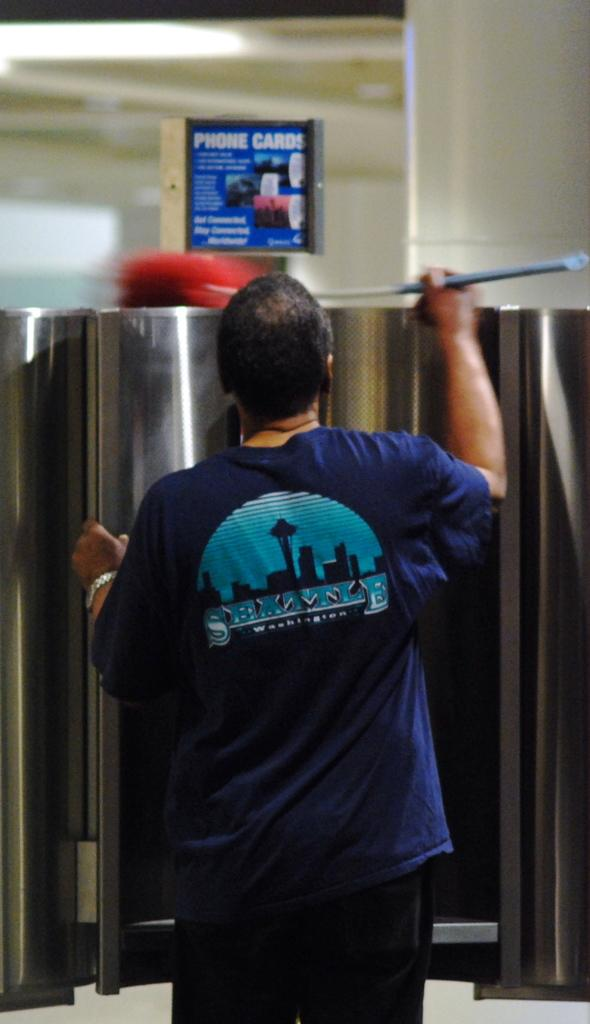Who is present in the image? There is a man in the image. What is the man doing in the image? The man is using a brush to remove dust. What object is present in the image that might be related to the man's activity? There is a metal cage in the image. How many yaks can be seen in the image? There are no yaks present in the image. What type of floor is visible in the image? The facts provided do not mention the floor, so we cannot determine its type from the image. 